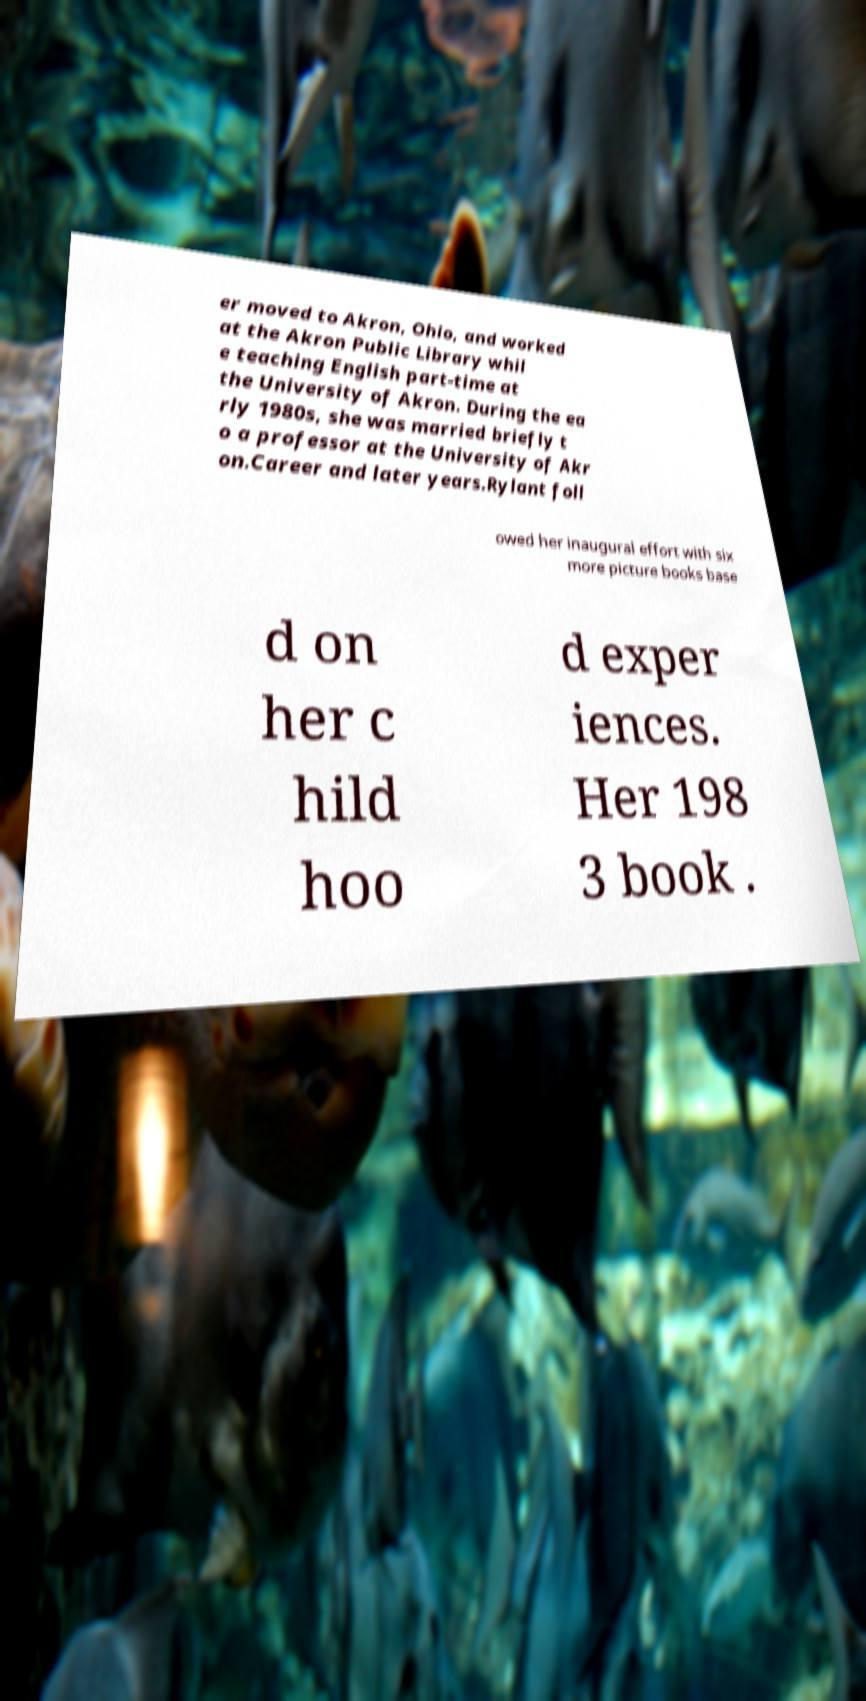Could you assist in decoding the text presented in this image and type it out clearly? er moved to Akron, Ohio, and worked at the Akron Public Library whil e teaching English part-time at the University of Akron. During the ea rly 1980s, she was married briefly t o a professor at the University of Akr on.Career and later years.Rylant foll owed her inaugural effort with six more picture books base d on her c hild hoo d exper iences. Her 198 3 book . 